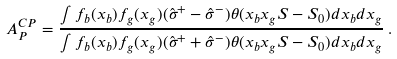Convert formula to latex. <formula><loc_0><loc_0><loc_500><loc_500>A _ { P } ^ { C P } = \frac { \int f _ { b } ( x _ { b } ) f _ { g } ( x _ { g } ) ( \hat { \sigma } ^ { + } - \hat { \sigma } ^ { - } ) \theta ( x _ { b } x _ { g } S - S _ { 0 } ) d x _ { b } d x _ { g } } { \int f _ { b } ( x _ { b } ) f _ { g } ( x _ { g } ) ( \hat { \sigma } ^ { + } + \hat { \sigma } ^ { - } ) \theta ( x _ { b } x _ { g } S - S _ { 0 } ) d x _ { b } d x _ { g } } \, .</formula> 